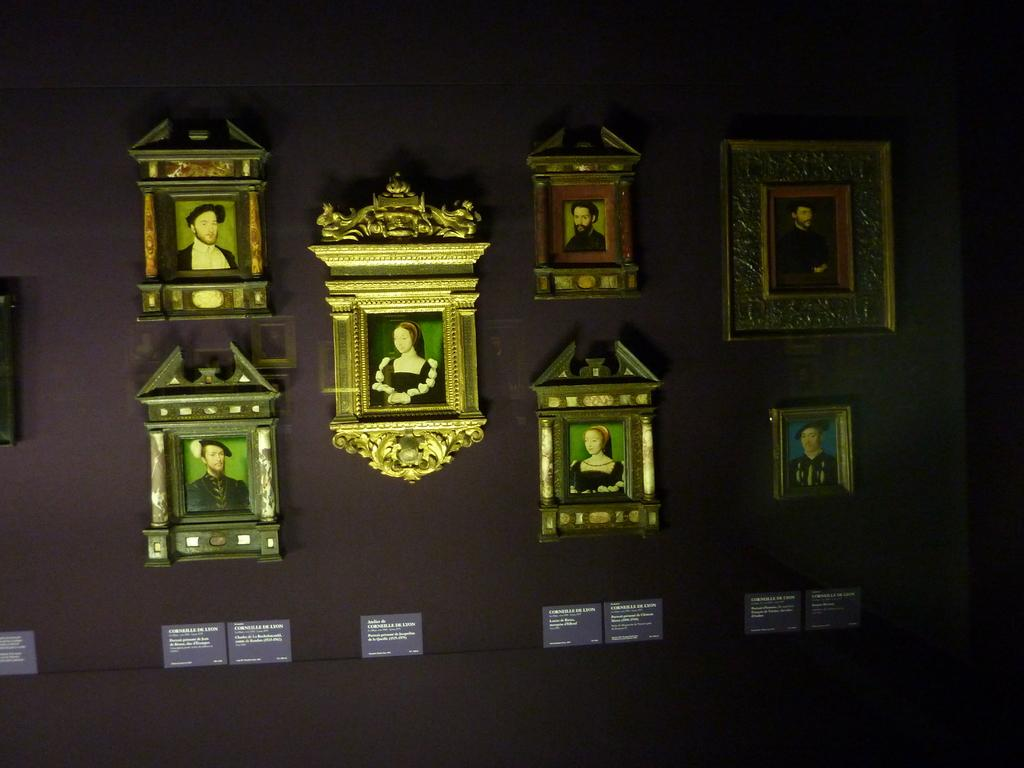What is hanging on the wall in the image? There are photo frames on the wall in the image. What else can be seen below the photo frames? There are boards with text below the frames in the image. What type of butter is being served by the servant in the image? There is no butter or servant present in the image; it only features photo frames and boards with text. 